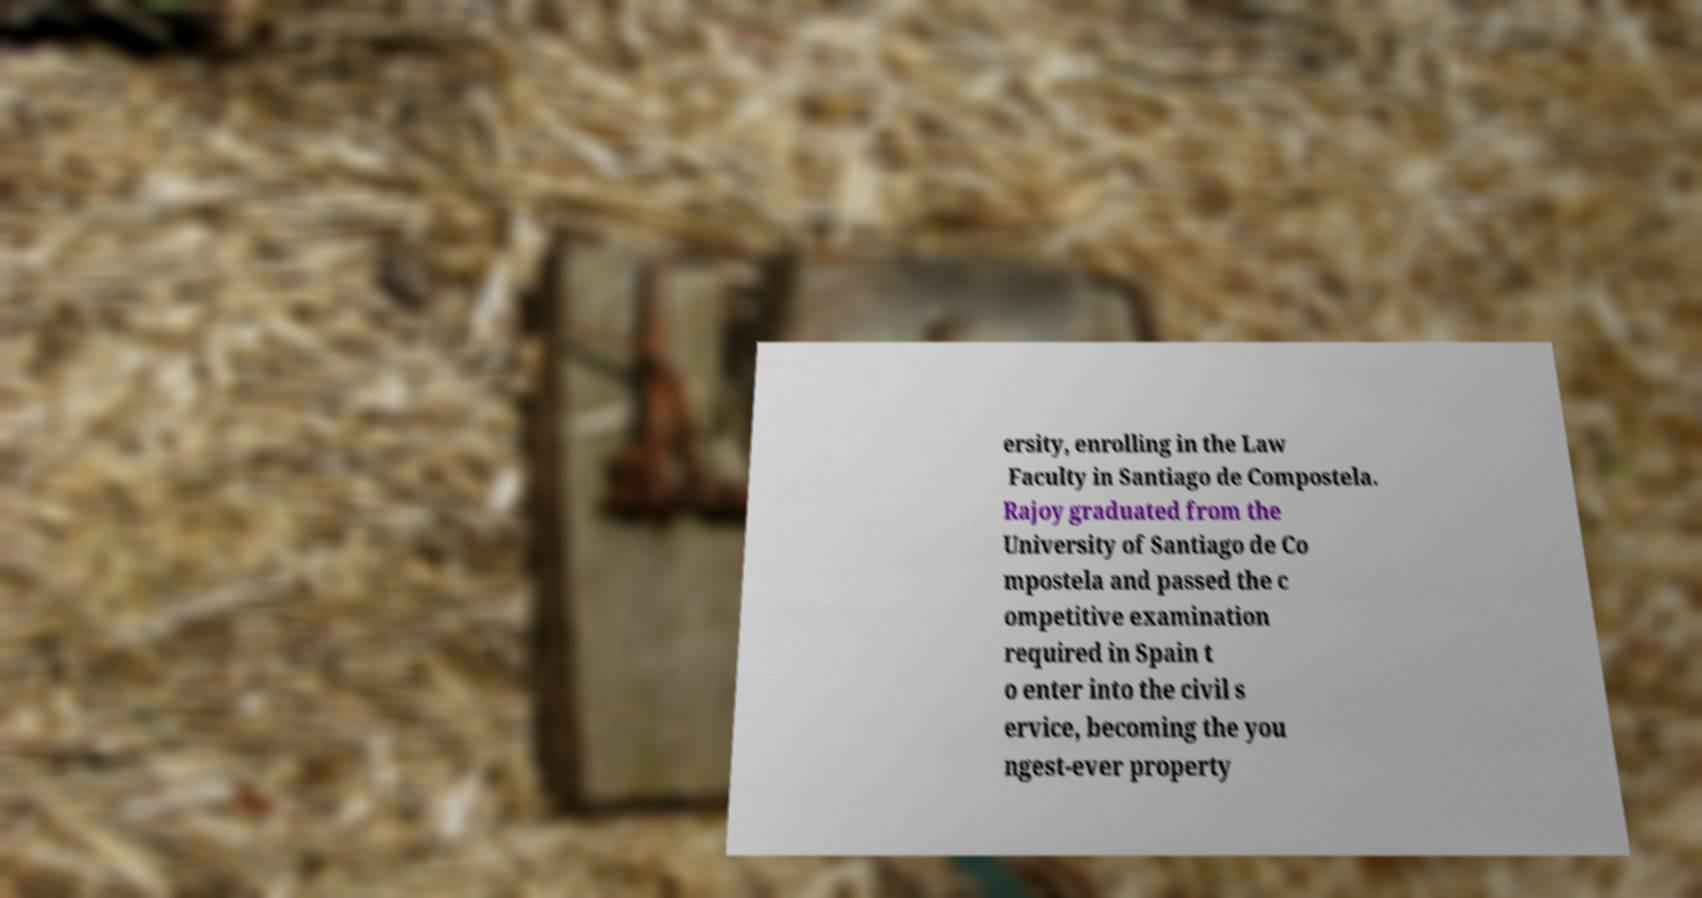There's text embedded in this image that I need extracted. Can you transcribe it verbatim? ersity, enrolling in the Law Faculty in Santiago de Compostela. Rajoy graduated from the University of Santiago de Co mpostela and passed the c ompetitive examination required in Spain t o enter into the civil s ervice, becoming the you ngest-ever property 